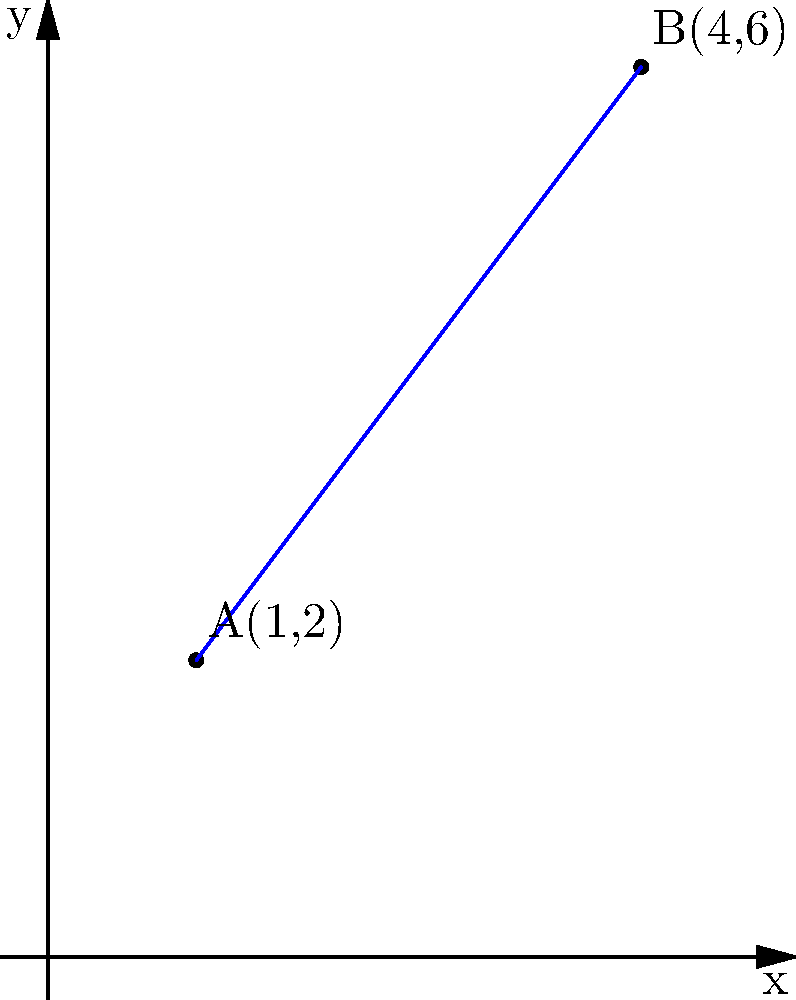In a study of immune cell migration, two T cells are tracked on a coordinate plane representing a tissue section. T cell A is located at point (1,2), and T cell B is at point (4,6). Calculate the Euclidean distance between these two cells to determine their proximity. Round your answer to two decimal places. To find the distance between two points on a coordinate plane, we can use the distance formula, which is derived from the Pythagorean theorem:

$$d = \sqrt{(x_2 - x_1)^2 + (y_2 - y_1)^2}$$

Where $(x_1, y_1)$ are the coordinates of the first point and $(x_2, y_2)$ are the coordinates of the second point.

Let's solve this step-by-step:

1) Identify the coordinates:
   Point A: $(x_1, y_1) = (1, 2)$
   Point B: $(x_2, y_2) = (4, 6)$

2) Plug these values into the distance formula:
   $$d = \sqrt{(4 - 1)^2 + (6 - 2)^2}$$

3) Simplify the expressions inside the parentheses:
   $$d = \sqrt{3^2 + 4^2}$$

4) Calculate the squares:
   $$d = \sqrt{9 + 16}$$

5) Add under the square root:
   $$d = \sqrt{25}$$

6) Calculate the square root:
   $$d = 5$$

The exact distance between the two T cells is 5 units.
Answer: 5 units 